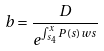Convert formula to latex. <formula><loc_0><loc_0><loc_500><loc_500>b = \frac { D } { e ^ { \int _ { s _ { 4 } } ^ { x } P ( s ) w s } }</formula> 